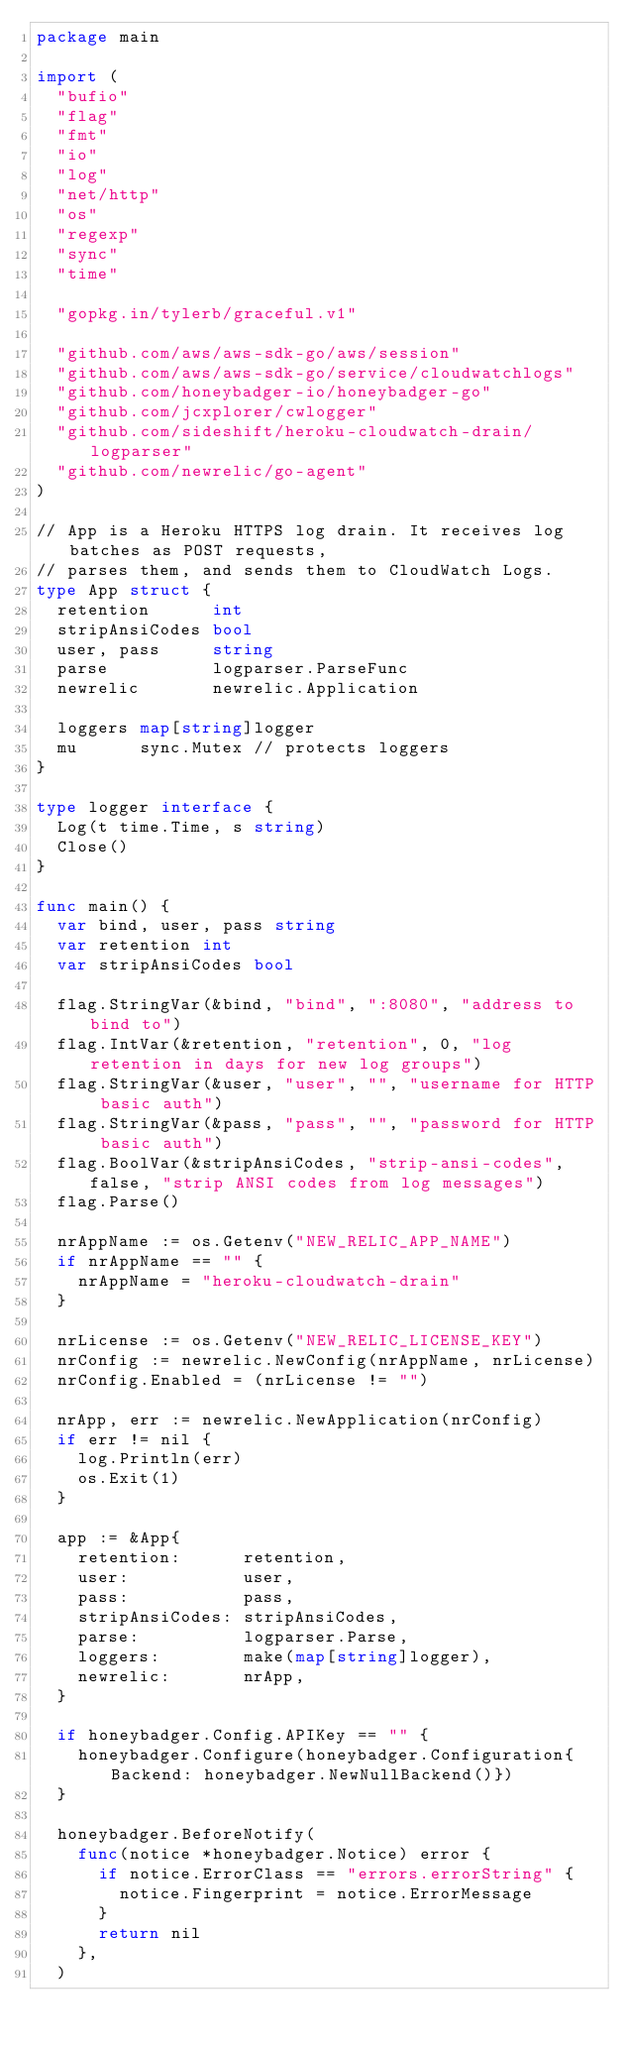<code> <loc_0><loc_0><loc_500><loc_500><_Go_>package main

import (
	"bufio"
	"flag"
	"fmt"
	"io"
	"log"
	"net/http"
	"os"
	"regexp"
	"sync"
	"time"

	"gopkg.in/tylerb/graceful.v1"

	"github.com/aws/aws-sdk-go/aws/session"
	"github.com/aws/aws-sdk-go/service/cloudwatchlogs"
	"github.com/honeybadger-io/honeybadger-go"
	"github.com/jcxplorer/cwlogger"
	"github.com/sideshift/heroku-cloudwatch-drain/logparser"
	"github.com/newrelic/go-agent"
)

// App is a Heroku HTTPS log drain. It receives log batches as POST requests,
// parses them, and sends them to CloudWatch Logs.
type App struct {
	retention      int
	stripAnsiCodes bool
	user, pass     string
	parse          logparser.ParseFunc
	newrelic       newrelic.Application

	loggers map[string]logger
	mu      sync.Mutex // protects loggers
}

type logger interface {
	Log(t time.Time, s string)
	Close()
}

func main() {
	var bind, user, pass string
	var retention int
	var stripAnsiCodes bool

	flag.StringVar(&bind, "bind", ":8080", "address to bind to")
	flag.IntVar(&retention, "retention", 0, "log retention in days for new log groups")
	flag.StringVar(&user, "user", "", "username for HTTP basic auth")
	flag.StringVar(&pass, "pass", "", "password for HTTP basic auth")
	flag.BoolVar(&stripAnsiCodes, "strip-ansi-codes", false, "strip ANSI codes from log messages")
	flag.Parse()

	nrAppName := os.Getenv("NEW_RELIC_APP_NAME")
	if nrAppName == "" {
		nrAppName = "heroku-cloudwatch-drain"
	}

	nrLicense := os.Getenv("NEW_RELIC_LICENSE_KEY")
	nrConfig := newrelic.NewConfig(nrAppName, nrLicense)
	nrConfig.Enabled = (nrLicense != "")

	nrApp, err := newrelic.NewApplication(nrConfig)
	if err != nil {
		log.Println(err)
		os.Exit(1)
	}

	app := &App{
		retention:      retention,
		user:           user,
		pass:           pass,
		stripAnsiCodes: stripAnsiCodes,
		parse:          logparser.Parse,
		loggers:        make(map[string]logger),
		newrelic:       nrApp,
	}

	if honeybadger.Config.APIKey == "" {
		honeybadger.Configure(honeybadger.Configuration{Backend: honeybadger.NewNullBackend()})
	}

	honeybadger.BeforeNotify(
		func(notice *honeybadger.Notice) error {
			if notice.ErrorClass == "errors.errorString" {
				notice.Fingerprint = notice.ErrorMessage
			}
			return nil
		},
	)
</code> 